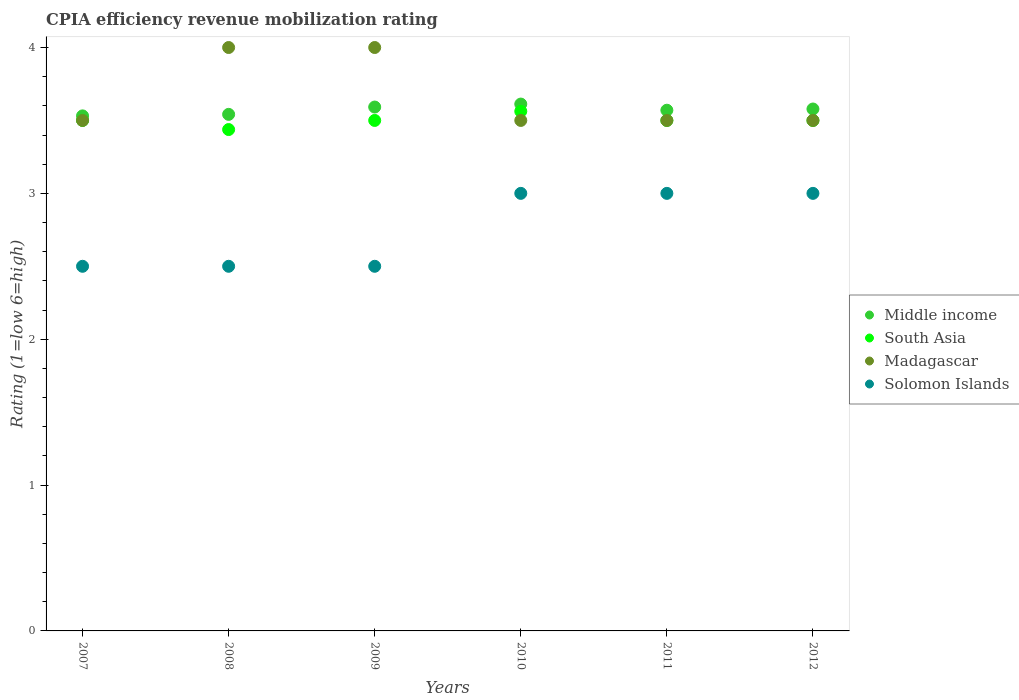Across all years, what is the maximum CPIA rating in Madagascar?
Ensure brevity in your answer.  4. Across all years, what is the minimum CPIA rating in Solomon Islands?
Provide a short and direct response. 2.5. In which year was the CPIA rating in Solomon Islands maximum?
Your answer should be compact. 2010. What is the total CPIA rating in Middle income in the graph?
Offer a very short reply. 21.43. What is the difference between the CPIA rating in Madagascar in 2009 and the CPIA rating in Middle income in 2010?
Your answer should be very brief. 0.39. What is the average CPIA rating in Solomon Islands per year?
Your response must be concise. 2.75. In the year 2007, what is the difference between the CPIA rating in Middle income and CPIA rating in Madagascar?
Your answer should be very brief. 0.03. In how many years, is the CPIA rating in Middle income greater than 3.2?
Ensure brevity in your answer.  6. What is the ratio of the CPIA rating in Solomon Islands in 2007 to that in 2010?
Offer a terse response. 0.83. What is the difference between the highest and the second highest CPIA rating in South Asia?
Provide a short and direct response. 0.06. In how many years, is the CPIA rating in Solomon Islands greater than the average CPIA rating in Solomon Islands taken over all years?
Your answer should be very brief. 3. Is the sum of the CPIA rating in Madagascar in 2008 and 2009 greater than the maximum CPIA rating in South Asia across all years?
Make the answer very short. Yes. Is it the case that in every year, the sum of the CPIA rating in South Asia and CPIA rating in Madagascar  is greater than the sum of CPIA rating in Solomon Islands and CPIA rating in Middle income?
Offer a very short reply. No. Is it the case that in every year, the sum of the CPIA rating in Solomon Islands and CPIA rating in South Asia  is greater than the CPIA rating in Madagascar?
Keep it short and to the point. Yes. Does the CPIA rating in Middle income monotonically increase over the years?
Your answer should be compact. No. Is the CPIA rating in Madagascar strictly greater than the CPIA rating in Solomon Islands over the years?
Provide a succinct answer. Yes. How many dotlines are there?
Keep it short and to the point. 4. What is the difference between two consecutive major ticks on the Y-axis?
Give a very brief answer. 1. Does the graph contain any zero values?
Your response must be concise. No. What is the title of the graph?
Your answer should be very brief. CPIA efficiency revenue mobilization rating. What is the label or title of the X-axis?
Provide a succinct answer. Years. What is the label or title of the Y-axis?
Your answer should be very brief. Rating (1=low 6=high). What is the Rating (1=low 6=high) in Middle income in 2007?
Offer a very short reply. 3.53. What is the Rating (1=low 6=high) of South Asia in 2007?
Make the answer very short. 3.5. What is the Rating (1=low 6=high) in Madagascar in 2007?
Provide a succinct answer. 3.5. What is the Rating (1=low 6=high) of Solomon Islands in 2007?
Provide a succinct answer. 2.5. What is the Rating (1=low 6=high) in Middle income in 2008?
Make the answer very short. 3.54. What is the Rating (1=low 6=high) in South Asia in 2008?
Provide a short and direct response. 3.44. What is the Rating (1=low 6=high) of Madagascar in 2008?
Your answer should be compact. 4. What is the Rating (1=low 6=high) of Solomon Islands in 2008?
Your answer should be compact. 2.5. What is the Rating (1=low 6=high) of Middle income in 2009?
Provide a short and direct response. 3.59. What is the Rating (1=low 6=high) of Middle income in 2010?
Offer a very short reply. 3.61. What is the Rating (1=low 6=high) of South Asia in 2010?
Provide a succinct answer. 3.56. What is the Rating (1=low 6=high) of Madagascar in 2010?
Your answer should be very brief. 3.5. What is the Rating (1=low 6=high) in Middle income in 2011?
Your response must be concise. 3.57. What is the Rating (1=low 6=high) in Madagascar in 2011?
Provide a succinct answer. 3.5. What is the Rating (1=low 6=high) of Solomon Islands in 2011?
Provide a succinct answer. 3. What is the Rating (1=low 6=high) in Middle income in 2012?
Your answer should be compact. 3.58. What is the Rating (1=low 6=high) of South Asia in 2012?
Make the answer very short. 3.5. What is the Rating (1=low 6=high) in Madagascar in 2012?
Make the answer very short. 3.5. What is the Rating (1=low 6=high) in Solomon Islands in 2012?
Ensure brevity in your answer.  3. Across all years, what is the maximum Rating (1=low 6=high) of Middle income?
Offer a terse response. 3.61. Across all years, what is the maximum Rating (1=low 6=high) in South Asia?
Your answer should be compact. 3.56. Across all years, what is the minimum Rating (1=low 6=high) of Middle income?
Provide a succinct answer. 3.53. Across all years, what is the minimum Rating (1=low 6=high) of South Asia?
Offer a very short reply. 3.44. Across all years, what is the minimum Rating (1=low 6=high) in Madagascar?
Ensure brevity in your answer.  3.5. What is the total Rating (1=low 6=high) in Middle income in the graph?
Offer a terse response. 21.43. What is the total Rating (1=low 6=high) of South Asia in the graph?
Your answer should be very brief. 21. What is the difference between the Rating (1=low 6=high) of Middle income in 2007 and that in 2008?
Your answer should be very brief. -0.01. What is the difference between the Rating (1=low 6=high) of South Asia in 2007 and that in 2008?
Provide a short and direct response. 0.06. What is the difference between the Rating (1=low 6=high) in Middle income in 2007 and that in 2009?
Your answer should be very brief. -0.06. What is the difference between the Rating (1=low 6=high) in Madagascar in 2007 and that in 2009?
Your answer should be compact. -0.5. What is the difference between the Rating (1=low 6=high) of Solomon Islands in 2007 and that in 2009?
Ensure brevity in your answer.  0. What is the difference between the Rating (1=low 6=high) of Middle income in 2007 and that in 2010?
Provide a short and direct response. -0.08. What is the difference between the Rating (1=low 6=high) in South Asia in 2007 and that in 2010?
Provide a succinct answer. -0.06. What is the difference between the Rating (1=low 6=high) in Madagascar in 2007 and that in 2010?
Offer a very short reply. 0. What is the difference between the Rating (1=low 6=high) of Solomon Islands in 2007 and that in 2010?
Provide a succinct answer. -0.5. What is the difference between the Rating (1=low 6=high) of Middle income in 2007 and that in 2011?
Your answer should be compact. -0.04. What is the difference between the Rating (1=low 6=high) of South Asia in 2007 and that in 2011?
Ensure brevity in your answer.  0. What is the difference between the Rating (1=low 6=high) of Middle income in 2007 and that in 2012?
Ensure brevity in your answer.  -0.05. What is the difference between the Rating (1=low 6=high) of Middle income in 2008 and that in 2009?
Give a very brief answer. -0.05. What is the difference between the Rating (1=low 6=high) of South Asia in 2008 and that in 2009?
Provide a succinct answer. -0.06. What is the difference between the Rating (1=low 6=high) in Madagascar in 2008 and that in 2009?
Your response must be concise. 0. What is the difference between the Rating (1=low 6=high) in Middle income in 2008 and that in 2010?
Keep it short and to the point. -0.07. What is the difference between the Rating (1=low 6=high) in South Asia in 2008 and that in 2010?
Offer a terse response. -0.12. What is the difference between the Rating (1=low 6=high) in Madagascar in 2008 and that in 2010?
Provide a short and direct response. 0.5. What is the difference between the Rating (1=low 6=high) in Solomon Islands in 2008 and that in 2010?
Your response must be concise. -0.5. What is the difference between the Rating (1=low 6=high) of Middle income in 2008 and that in 2011?
Keep it short and to the point. -0.03. What is the difference between the Rating (1=low 6=high) of South Asia in 2008 and that in 2011?
Provide a succinct answer. -0.06. What is the difference between the Rating (1=low 6=high) of Solomon Islands in 2008 and that in 2011?
Your answer should be very brief. -0.5. What is the difference between the Rating (1=low 6=high) of Middle income in 2008 and that in 2012?
Keep it short and to the point. -0.04. What is the difference between the Rating (1=low 6=high) of South Asia in 2008 and that in 2012?
Your answer should be very brief. -0.06. What is the difference between the Rating (1=low 6=high) of Madagascar in 2008 and that in 2012?
Give a very brief answer. 0.5. What is the difference between the Rating (1=low 6=high) of Solomon Islands in 2008 and that in 2012?
Provide a short and direct response. -0.5. What is the difference between the Rating (1=low 6=high) of Middle income in 2009 and that in 2010?
Offer a terse response. -0.02. What is the difference between the Rating (1=low 6=high) in South Asia in 2009 and that in 2010?
Ensure brevity in your answer.  -0.06. What is the difference between the Rating (1=low 6=high) of Madagascar in 2009 and that in 2010?
Offer a very short reply. 0.5. What is the difference between the Rating (1=low 6=high) in Middle income in 2009 and that in 2011?
Make the answer very short. 0.02. What is the difference between the Rating (1=low 6=high) of Madagascar in 2009 and that in 2011?
Offer a very short reply. 0.5. What is the difference between the Rating (1=low 6=high) of Middle income in 2009 and that in 2012?
Make the answer very short. 0.01. What is the difference between the Rating (1=low 6=high) of South Asia in 2009 and that in 2012?
Your answer should be compact. 0. What is the difference between the Rating (1=low 6=high) in Madagascar in 2009 and that in 2012?
Offer a terse response. 0.5. What is the difference between the Rating (1=low 6=high) in Solomon Islands in 2009 and that in 2012?
Your response must be concise. -0.5. What is the difference between the Rating (1=low 6=high) in Middle income in 2010 and that in 2011?
Provide a short and direct response. 0.04. What is the difference between the Rating (1=low 6=high) of South Asia in 2010 and that in 2011?
Provide a short and direct response. 0.06. What is the difference between the Rating (1=low 6=high) in Madagascar in 2010 and that in 2011?
Provide a short and direct response. 0. What is the difference between the Rating (1=low 6=high) of Solomon Islands in 2010 and that in 2011?
Offer a very short reply. 0. What is the difference between the Rating (1=low 6=high) in Middle income in 2010 and that in 2012?
Give a very brief answer. 0.03. What is the difference between the Rating (1=low 6=high) in South Asia in 2010 and that in 2012?
Your response must be concise. 0.06. What is the difference between the Rating (1=low 6=high) of Solomon Islands in 2010 and that in 2012?
Make the answer very short. 0. What is the difference between the Rating (1=low 6=high) in Middle income in 2011 and that in 2012?
Make the answer very short. -0.01. What is the difference between the Rating (1=low 6=high) of Madagascar in 2011 and that in 2012?
Provide a short and direct response. 0. What is the difference between the Rating (1=low 6=high) of Middle income in 2007 and the Rating (1=low 6=high) of South Asia in 2008?
Provide a short and direct response. 0.09. What is the difference between the Rating (1=low 6=high) in Middle income in 2007 and the Rating (1=low 6=high) in Madagascar in 2008?
Provide a succinct answer. -0.47. What is the difference between the Rating (1=low 6=high) in Middle income in 2007 and the Rating (1=low 6=high) in Solomon Islands in 2008?
Offer a very short reply. 1.03. What is the difference between the Rating (1=low 6=high) of South Asia in 2007 and the Rating (1=low 6=high) of Solomon Islands in 2008?
Your answer should be very brief. 1. What is the difference between the Rating (1=low 6=high) in Middle income in 2007 and the Rating (1=low 6=high) in South Asia in 2009?
Your answer should be very brief. 0.03. What is the difference between the Rating (1=low 6=high) of Middle income in 2007 and the Rating (1=low 6=high) of Madagascar in 2009?
Ensure brevity in your answer.  -0.47. What is the difference between the Rating (1=low 6=high) in Middle income in 2007 and the Rating (1=low 6=high) in Solomon Islands in 2009?
Make the answer very short. 1.03. What is the difference between the Rating (1=low 6=high) of Madagascar in 2007 and the Rating (1=low 6=high) of Solomon Islands in 2009?
Your answer should be compact. 1. What is the difference between the Rating (1=low 6=high) of Middle income in 2007 and the Rating (1=low 6=high) of South Asia in 2010?
Provide a short and direct response. -0.03. What is the difference between the Rating (1=low 6=high) of Middle income in 2007 and the Rating (1=low 6=high) of Madagascar in 2010?
Ensure brevity in your answer.  0.03. What is the difference between the Rating (1=low 6=high) of Middle income in 2007 and the Rating (1=low 6=high) of Solomon Islands in 2010?
Keep it short and to the point. 0.53. What is the difference between the Rating (1=low 6=high) of Madagascar in 2007 and the Rating (1=low 6=high) of Solomon Islands in 2010?
Make the answer very short. 0.5. What is the difference between the Rating (1=low 6=high) of Middle income in 2007 and the Rating (1=low 6=high) of South Asia in 2011?
Give a very brief answer. 0.03. What is the difference between the Rating (1=low 6=high) of Middle income in 2007 and the Rating (1=low 6=high) of Madagascar in 2011?
Your answer should be very brief. 0.03. What is the difference between the Rating (1=low 6=high) of Middle income in 2007 and the Rating (1=low 6=high) of Solomon Islands in 2011?
Ensure brevity in your answer.  0.53. What is the difference between the Rating (1=low 6=high) in South Asia in 2007 and the Rating (1=low 6=high) in Madagascar in 2011?
Provide a succinct answer. 0. What is the difference between the Rating (1=low 6=high) in South Asia in 2007 and the Rating (1=low 6=high) in Solomon Islands in 2011?
Your response must be concise. 0.5. What is the difference between the Rating (1=low 6=high) of Madagascar in 2007 and the Rating (1=low 6=high) of Solomon Islands in 2011?
Your response must be concise. 0.5. What is the difference between the Rating (1=low 6=high) of Middle income in 2007 and the Rating (1=low 6=high) of South Asia in 2012?
Your response must be concise. 0.03. What is the difference between the Rating (1=low 6=high) in Middle income in 2007 and the Rating (1=low 6=high) in Madagascar in 2012?
Your answer should be compact. 0.03. What is the difference between the Rating (1=low 6=high) of Middle income in 2007 and the Rating (1=low 6=high) of Solomon Islands in 2012?
Offer a terse response. 0.53. What is the difference between the Rating (1=low 6=high) of South Asia in 2007 and the Rating (1=low 6=high) of Madagascar in 2012?
Offer a very short reply. 0. What is the difference between the Rating (1=low 6=high) of Madagascar in 2007 and the Rating (1=low 6=high) of Solomon Islands in 2012?
Ensure brevity in your answer.  0.5. What is the difference between the Rating (1=low 6=high) of Middle income in 2008 and the Rating (1=low 6=high) of South Asia in 2009?
Keep it short and to the point. 0.04. What is the difference between the Rating (1=low 6=high) in Middle income in 2008 and the Rating (1=low 6=high) in Madagascar in 2009?
Offer a very short reply. -0.46. What is the difference between the Rating (1=low 6=high) of Middle income in 2008 and the Rating (1=low 6=high) of Solomon Islands in 2009?
Your answer should be very brief. 1.04. What is the difference between the Rating (1=low 6=high) in South Asia in 2008 and the Rating (1=low 6=high) in Madagascar in 2009?
Your response must be concise. -0.56. What is the difference between the Rating (1=low 6=high) in South Asia in 2008 and the Rating (1=low 6=high) in Solomon Islands in 2009?
Your response must be concise. 0.94. What is the difference between the Rating (1=low 6=high) in Madagascar in 2008 and the Rating (1=low 6=high) in Solomon Islands in 2009?
Offer a terse response. 1.5. What is the difference between the Rating (1=low 6=high) in Middle income in 2008 and the Rating (1=low 6=high) in South Asia in 2010?
Provide a short and direct response. -0.02. What is the difference between the Rating (1=low 6=high) in Middle income in 2008 and the Rating (1=low 6=high) in Madagascar in 2010?
Ensure brevity in your answer.  0.04. What is the difference between the Rating (1=low 6=high) of Middle income in 2008 and the Rating (1=low 6=high) of Solomon Islands in 2010?
Your answer should be compact. 0.54. What is the difference between the Rating (1=low 6=high) in South Asia in 2008 and the Rating (1=low 6=high) in Madagascar in 2010?
Ensure brevity in your answer.  -0.06. What is the difference between the Rating (1=low 6=high) of South Asia in 2008 and the Rating (1=low 6=high) of Solomon Islands in 2010?
Keep it short and to the point. 0.44. What is the difference between the Rating (1=low 6=high) of Madagascar in 2008 and the Rating (1=low 6=high) of Solomon Islands in 2010?
Your answer should be very brief. 1. What is the difference between the Rating (1=low 6=high) of Middle income in 2008 and the Rating (1=low 6=high) of South Asia in 2011?
Ensure brevity in your answer.  0.04. What is the difference between the Rating (1=low 6=high) in Middle income in 2008 and the Rating (1=low 6=high) in Madagascar in 2011?
Provide a succinct answer. 0.04. What is the difference between the Rating (1=low 6=high) of Middle income in 2008 and the Rating (1=low 6=high) of Solomon Islands in 2011?
Ensure brevity in your answer.  0.54. What is the difference between the Rating (1=low 6=high) of South Asia in 2008 and the Rating (1=low 6=high) of Madagascar in 2011?
Your answer should be compact. -0.06. What is the difference between the Rating (1=low 6=high) in South Asia in 2008 and the Rating (1=low 6=high) in Solomon Islands in 2011?
Provide a short and direct response. 0.44. What is the difference between the Rating (1=low 6=high) of Middle income in 2008 and the Rating (1=low 6=high) of South Asia in 2012?
Your response must be concise. 0.04. What is the difference between the Rating (1=low 6=high) of Middle income in 2008 and the Rating (1=low 6=high) of Madagascar in 2012?
Ensure brevity in your answer.  0.04. What is the difference between the Rating (1=low 6=high) of Middle income in 2008 and the Rating (1=low 6=high) of Solomon Islands in 2012?
Ensure brevity in your answer.  0.54. What is the difference between the Rating (1=low 6=high) of South Asia in 2008 and the Rating (1=low 6=high) of Madagascar in 2012?
Ensure brevity in your answer.  -0.06. What is the difference between the Rating (1=low 6=high) of South Asia in 2008 and the Rating (1=low 6=high) of Solomon Islands in 2012?
Keep it short and to the point. 0.44. What is the difference between the Rating (1=low 6=high) of Middle income in 2009 and the Rating (1=low 6=high) of South Asia in 2010?
Make the answer very short. 0.03. What is the difference between the Rating (1=low 6=high) of Middle income in 2009 and the Rating (1=low 6=high) of Madagascar in 2010?
Your response must be concise. 0.09. What is the difference between the Rating (1=low 6=high) in Middle income in 2009 and the Rating (1=low 6=high) in Solomon Islands in 2010?
Ensure brevity in your answer.  0.59. What is the difference between the Rating (1=low 6=high) of South Asia in 2009 and the Rating (1=low 6=high) of Madagascar in 2010?
Give a very brief answer. 0. What is the difference between the Rating (1=low 6=high) in South Asia in 2009 and the Rating (1=low 6=high) in Solomon Islands in 2010?
Provide a succinct answer. 0.5. What is the difference between the Rating (1=low 6=high) of Madagascar in 2009 and the Rating (1=low 6=high) of Solomon Islands in 2010?
Keep it short and to the point. 1. What is the difference between the Rating (1=low 6=high) of Middle income in 2009 and the Rating (1=low 6=high) of South Asia in 2011?
Your response must be concise. 0.09. What is the difference between the Rating (1=low 6=high) of Middle income in 2009 and the Rating (1=low 6=high) of Madagascar in 2011?
Offer a very short reply. 0.09. What is the difference between the Rating (1=low 6=high) in Middle income in 2009 and the Rating (1=low 6=high) in Solomon Islands in 2011?
Provide a succinct answer. 0.59. What is the difference between the Rating (1=low 6=high) in Madagascar in 2009 and the Rating (1=low 6=high) in Solomon Islands in 2011?
Provide a succinct answer. 1. What is the difference between the Rating (1=low 6=high) in Middle income in 2009 and the Rating (1=low 6=high) in South Asia in 2012?
Make the answer very short. 0.09. What is the difference between the Rating (1=low 6=high) in Middle income in 2009 and the Rating (1=low 6=high) in Madagascar in 2012?
Your response must be concise. 0.09. What is the difference between the Rating (1=low 6=high) of Middle income in 2009 and the Rating (1=low 6=high) of Solomon Islands in 2012?
Your answer should be very brief. 0.59. What is the difference between the Rating (1=low 6=high) of South Asia in 2009 and the Rating (1=low 6=high) of Madagascar in 2012?
Provide a succinct answer. 0. What is the difference between the Rating (1=low 6=high) in Madagascar in 2009 and the Rating (1=low 6=high) in Solomon Islands in 2012?
Offer a terse response. 1. What is the difference between the Rating (1=low 6=high) of Middle income in 2010 and the Rating (1=low 6=high) of South Asia in 2011?
Keep it short and to the point. 0.11. What is the difference between the Rating (1=low 6=high) in Middle income in 2010 and the Rating (1=low 6=high) in Madagascar in 2011?
Your response must be concise. 0.11. What is the difference between the Rating (1=low 6=high) of Middle income in 2010 and the Rating (1=low 6=high) of Solomon Islands in 2011?
Provide a succinct answer. 0.61. What is the difference between the Rating (1=low 6=high) of South Asia in 2010 and the Rating (1=low 6=high) of Madagascar in 2011?
Provide a succinct answer. 0.06. What is the difference between the Rating (1=low 6=high) of South Asia in 2010 and the Rating (1=low 6=high) of Solomon Islands in 2011?
Ensure brevity in your answer.  0.56. What is the difference between the Rating (1=low 6=high) in Madagascar in 2010 and the Rating (1=low 6=high) in Solomon Islands in 2011?
Offer a very short reply. 0.5. What is the difference between the Rating (1=low 6=high) of Middle income in 2010 and the Rating (1=low 6=high) of South Asia in 2012?
Offer a very short reply. 0.11. What is the difference between the Rating (1=low 6=high) of Middle income in 2010 and the Rating (1=low 6=high) of Madagascar in 2012?
Your answer should be compact. 0.11. What is the difference between the Rating (1=low 6=high) of Middle income in 2010 and the Rating (1=low 6=high) of Solomon Islands in 2012?
Your answer should be very brief. 0.61. What is the difference between the Rating (1=low 6=high) in South Asia in 2010 and the Rating (1=low 6=high) in Madagascar in 2012?
Ensure brevity in your answer.  0.06. What is the difference between the Rating (1=low 6=high) in South Asia in 2010 and the Rating (1=low 6=high) in Solomon Islands in 2012?
Make the answer very short. 0.56. What is the difference between the Rating (1=low 6=high) of Madagascar in 2010 and the Rating (1=low 6=high) of Solomon Islands in 2012?
Offer a terse response. 0.5. What is the difference between the Rating (1=low 6=high) in Middle income in 2011 and the Rating (1=low 6=high) in South Asia in 2012?
Ensure brevity in your answer.  0.07. What is the difference between the Rating (1=low 6=high) of Middle income in 2011 and the Rating (1=low 6=high) of Madagascar in 2012?
Offer a terse response. 0.07. What is the difference between the Rating (1=low 6=high) in Middle income in 2011 and the Rating (1=low 6=high) in Solomon Islands in 2012?
Provide a succinct answer. 0.57. What is the difference between the Rating (1=low 6=high) of South Asia in 2011 and the Rating (1=low 6=high) of Madagascar in 2012?
Provide a short and direct response. 0. What is the difference between the Rating (1=low 6=high) of South Asia in 2011 and the Rating (1=low 6=high) of Solomon Islands in 2012?
Offer a terse response. 0.5. What is the average Rating (1=low 6=high) in Middle income per year?
Provide a succinct answer. 3.57. What is the average Rating (1=low 6=high) of South Asia per year?
Offer a terse response. 3.5. What is the average Rating (1=low 6=high) in Madagascar per year?
Give a very brief answer. 3.67. What is the average Rating (1=low 6=high) of Solomon Islands per year?
Your answer should be compact. 2.75. In the year 2007, what is the difference between the Rating (1=low 6=high) of Middle income and Rating (1=low 6=high) of South Asia?
Provide a succinct answer. 0.03. In the year 2007, what is the difference between the Rating (1=low 6=high) in Middle income and Rating (1=low 6=high) in Madagascar?
Your response must be concise. 0.03. In the year 2007, what is the difference between the Rating (1=low 6=high) in Middle income and Rating (1=low 6=high) in Solomon Islands?
Keep it short and to the point. 1.03. In the year 2007, what is the difference between the Rating (1=low 6=high) of South Asia and Rating (1=low 6=high) of Solomon Islands?
Provide a succinct answer. 1. In the year 2007, what is the difference between the Rating (1=low 6=high) of Madagascar and Rating (1=low 6=high) of Solomon Islands?
Ensure brevity in your answer.  1. In the year 2008, what is the difference between the Rating (1=low 6=high) in Middle income and Rating (1=low 6=high) in South Asia?
Your answer should be compact. 0.1. In the year 2008, what is the difference between the Rating (1=low 6=high) of Middle income and Rating (1=low 6=high) of Madagascar?
Your response must be concise. -0.46. In the year 2008, what is the difference between the Rating (1=low 6=high) in Middle income and Rating (1=low 6=high) in Solomon Islands?
Your answer should be compact. 1.04. In the year 2008, what is the difference between the Rating (1=low 6=high) of South Asia and Rating (1=low 6=high) of Madagascar?
Offer a terse response. -0.56. In the year 2008, what is the difference between the Rating (1=low 6=high) of South Asia and Rating (1=low 6=high) of Solomon Islands?
Ensure brevity in your answer.  0.94. In the year 2008, what is the difference between the Rating (1=low 6=high) in Madagascar and Rating (1=low 6=high) in Solomon Islands?
Provide a short and direct response. 1.5. In the year 2009, what is the difference between the Rating (1=low 6=high) of Middle income and Rating (1=low 6=high) of South Asia?
Your answer should be compact. 0.09. In the year 2009, what is the difference between the Rating (1=low 6=high) of Middle income and Rating (1=low 6=high) of Madagascar?
Provide a short and direct response. -0.41. In the year 2009, what is the difference between the Rating (1=low 6=high) of Middle income and Rating (1=low 6=high) of Solomon Islands?
Offer a very short reply. 1.09. In the year 2010, what is the difference between the Rating (1=low 6=high) of Middle income and Rating (1=low 6=high) of South Asia?
Offer a very short reply. 0.05. In the year 2010, what is the difference between the Rating (1=low 6=high) in Middle income and Rating (1=low 6=high) in Madagascar?
Offer a very short reply. 0.11. In the year 2010, what is the difference between the Rating (1=low 6=high) of Middle income and Rating (1=low 6=high) of Solomon Islands?
Provide a short and direct response. 0.61. In the year 2010, what is the difference between the Rating (1=low 6=high) of South Asia and Rating (1=low 6=high) of Madagascar?
Your answer should be compact. 0.06. In the year 2010, what is the difference between the Rating (1=low 6=high) in South Asia and Rating (1=low 6=high) in Solomon Islands?
Keep it short and to the point. 0.56. In the year 2011, what is the difference between the Rating (1=low 6=high) of Middle income and Rating (1=low 6=high) of South Asia?
Make the answer very short. 0.07. In the year 2011, what is the difference between the Rating (1=low 6=high) in Middle income and Rating (1=low 6=high) in Madagascar?
Make the answer very short. 0.07. In the year 2011, what is the difference between the Rating (1=low 6=high) in Middle income and Rating (1=low 6=high) in Solomon Islands?
Your answer should be compact. 0.57. In the year 2011, what is the difference between the Rating (1=low 6=high) of South Asia and Rating (1=low 6=high) of Madagascar?
Your answer should be compact. 0. In the year 2011, what is the difference between the Rating (1=low 6=high) of South Asia and Rating (1=low 6=high) of Solomon Islands?
Keep it short and to the point. 0.5. In the year 2012, what is the difference between the Rating (1=low 6=high) of Middle income and Rating (1=low 6=high) of South Asia?
Offer a terse response. 0.08. In the year 2012, what is the difference between the Rating (1=low 6=high) of Middle income and Rating (1=low 6=high) of Madagascar?
Provide a short and direct response. 0.08. In the year 2012, what is the difference between the Rating (1=low 6=high) in Middle income and Rating (1=low 6=high) in Solomon Islands?
Your answer should be compact. 0.58. What is the ratio of the Rating (1=low 6=high) of Middle income in 2007 to that in 2008?
Offer a very short reply. 1. What is the ratio of the Rating (1=low 6=high) of South Asia in 2007 to that in 2008?
Your answer should be compact. 1.02. What is the ratio of the Rating (1=low 6=high) of Middle income in 2007 to that in 2009?
Provide a succinct answer. 0.98. What is the ratio of the Rating (1=low 6=high) in Madagascar in 2007 to that in 2009?
Make the answer very short. 0.88. What is the ratio of the Rating (1=low 6=high) of Middle income in 2007 to that in 2010?
Ensure brevity in your answer.  0.98. What is the ratio of the Rating (1=low 6=high) of South Asia in 2007 to that in 2010?
Provide a short and direct response. 0.98. What is the ratio of the Rating (1=low 6=high) of Madagascar in 2007 to that in 2010?
Give a very brief answer. 1. What is the ratio of the Rating (1=low 6=high) in Solomon Islands in 2007 to that in 2010?
Offer a very short reply. 0.83. What is the ratio of the Rating (1=low 6=high) in Middle income in 2007 to that in 2011?
Give a very brief answer. 0.99. What is the ratio of the Rating (1=low 6=high) in South Asia in 2007 to that in 2011?
Offer a terse response. 1. What is the ratio of the Rating (1=low 6=high) of Madagascar in 2007 to that in 2011?
Your answer should be very brief. 1. What is the ratio of the Rating (1=low 6=high) of Solomon Islands in 2007 to that in 2011?
Make the answer very short. 0.83. What is the ratio of the Rating (1=low 6=high) in Middle income in 2007 to that in 2012?
Offer a very short reply. 0.99. What is the ratio of the Rating (1=low 6=high) in Madagascar in 2007 to that in 2012?
Your answer should be very brief. 1. What is the ratio of the Rating (1=low 6=high) of South Asia in 2008 to that in 2009?
Your answer should be very brief. 0.98. What is the ratio of the Rating (1=low 6=high) in Solomon Islands in 2008 to that in 2009?
Offer a terse response. 1. What is the ratio of the Rating (1=low 6=high) in Middle income in 2008 to that in 2010?
Keep it short and to the point. 0.98. What is the ratio of the Rating (1=low 6=high) in South Asia in 2008 to that in 2010?
Offer a terse response. 0.96. What is the ratio of the Rating (1=low 6=high) of Solomon Islands in 2008 to that in 2010?
Your answer should be very brief. 0.83. What is the ratio of the Rating (1=low 6=high) in Middle income in 2008 to that in 2011?
Provide a succinct answer. 0.99. What is the ratio of the Rating (1=low 6=high) of South Asia in 2008 to that in 2011?
Give a very brief answer. 0.98. What is the ratio of the Rating (1=low 6=high) in Solomon Islands in 2008 to that in 2011?
Provide a short and direct response. 0.83. What is the ratio of the Rating (1=low 6=high) in Middle income in 2008 to that in 2012?
Provide a short and direct response. 0.99. What is the ratio of the Rating (1=low 6=high) in South Asia in 2008 to that in 2012?
Your answer should be very brief. 0.98. What is the ratio of the Rating (1=low 6=high) in Solomon Islands in 2008 to that in 2012?
Provide a short and direct response. 0.83. What is the ratio of the Rating (1=low 6=high) of South Asia in 2009 to that in 2010?
Offer a very short reply. 0.98. What is the ratio of the Rating (1=low 6=high) in Madagascar in 2009 to that in 2010?
Provide a short and direct response. 1.14. What is the ratio of the Rating (1=low 6=high) in Solomon Islands in 2009 to that in 2010?
Your response must be concise. 0.83. What is the ratio of the Rating (1=low 6=high) in Middle income in 2009 to that in 2011?
Keep it short and to the point. 1.01. What is the ratio of the Rating (1=low 6=high) in Madagascar in 2009 to that in 2012?
Make the answer very short. 1.14. What is the ratio of the Rating (1=low 6=high) of Middle income in 2010 to that in 2011?
Your answer should be very brief. 1.01. What is the ratio of the Rating (1=low 6=high) in South Asia in 2010 to that in 2011?
Keep it short and to the point. 1.02. What is the ratio of the Rating (1=low 6=high) of Solomon Islands in 2010 to that in 2011?
Provide a short and direct response. 1. What is the ratio of the Rating (1=low 6=high) in Middle income in 2010 to that in 2012?
Your answer should be very brief. 1.01. What is the ratio of the Rating (1=low 6=high) of South Asia in 2010 to that in 2012?
Your answer should be very brief. 1.02. What is the ratio of the Rating (1=low 6=high) in Solomon Islands in 2010 to that in 2012?
Offer a terse response. 1. What is the ratio of the Rating (1=low 6=high) of South Asia in 2011 to that in 2012?
Ensure brevity in your answer.  1. What is the ratio of the Rating (1=low 6=high) in Madagascar in 2011 to that in 2012?
Offer a terse response. 1. What is the ratio of the Rating (1=low 6=high) in Solomon Islands in 2011 to that in 2012?
Your response must be concise. 1. What is the difference between the highest and the second highest Rating (1=low 6=high) in Middle income?
Give a very brief answer. 0.02. What is the difference between the highest and the second highest Rating (1=low 6=high) in South Asia?
Offer a very short reply. 0.06. What is the difference between the highest and the second highest Rating (1=low 6=high) of Madagascar?
Offer a terse response. 0. What is the difference between the highest and the second highest Rating (1=low 6=high) in Solomon Islands?
Provide a succinct answer. 0. What is the difference between the highest and the lowest Rating (1=low 6=high) in Middle income?
Your response must be concise. 0.08. What is the difference between the highest and the lowest Rating (1=low 6=high) of South Asia?
Make the answer very short. 0.12. 